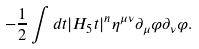<formula> <loc_0><loc_0><loc_500><loc_500>- \frac { 1 } { 2 } \int d t | H _ { 5 } t | ^ { n } \eta ^ { \mu \nu } \partial _ { \mu } \varphi \partial _ { \nu } \varphi .</formula> 